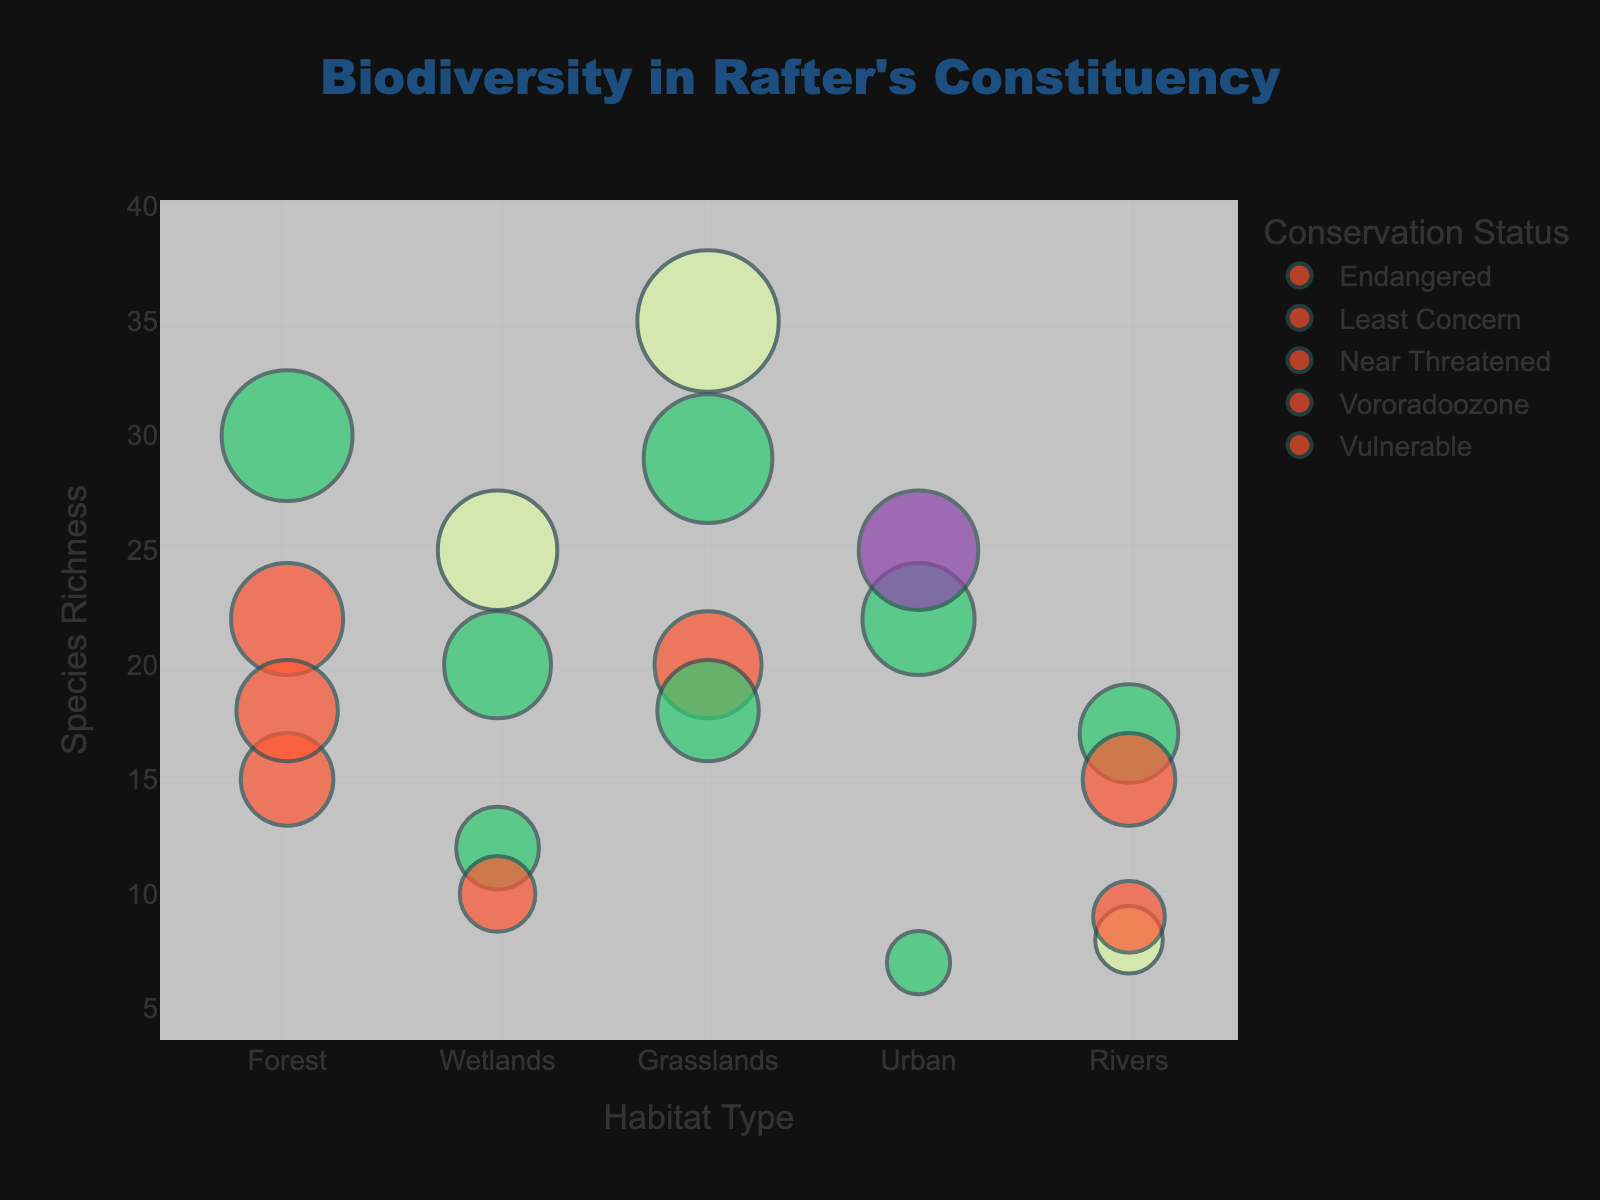What's the title of the chart? The title is displayed at the top of the chart.
Answer: Biodiversity in Rafter's Constituency How many habitats are represented in the chart? There are distinct categories on the x-axis representing different habitats. Counting them gives us the total number.
Answer: 5 Which habitat has the highest species richness for Bees? Locate the data points for Bees across different habitats and compare their species richness values. The highest value will be in Grasslands with a richness of 35.
Answer: Grasslands What is the conservation status of Otters in Rivers? Hover over or look for the data point representing Otters in Rivers. The color corresponding to Otters indicates their conservation status.
Answer: Vulnerable Which species in the Forest has the highest species richness? Check the data points within the Forest habitat and compare their species richness values. The highest value among them is for Butterflies with 30.
Answer: Butterflies Is there a habitat where more than one species are Endangered? Observe the data points colored for Endangered status, and identify if any habitat appears more than once. Bees in Grasslands and Frogs in Wetlands are Endangered.
Answer: No What’s the total species richness for species listed as "Near Threatened" in the chart? Look for data points with the "Near Threatened" status and sum their species richness values: Owls (18) + Mice (18) + Salamanders (8) = 44.
Answer: 44 Which has a higher species richness, Pigeons in Urban areas or Trout in Rivers? Compare the species richness values for Pigeons and Trout in their respective habitats. Pigeons have 22 and Trout has 17.
Answer: Pigeons What is the color associated with "Least Concern" species? Check the legend for the color corresponding to the "Least Concern" category.
Answer: Green How does the species richness of Dragonflies in Wetlands compare to Kingfishers in Rivers? Compare the species richness values for Dragonflies in Wetlands (20) and Kingfishers in Rivers (15). Dragonflies have a higher species richness.
Answer: Dragonflies have higher richness 